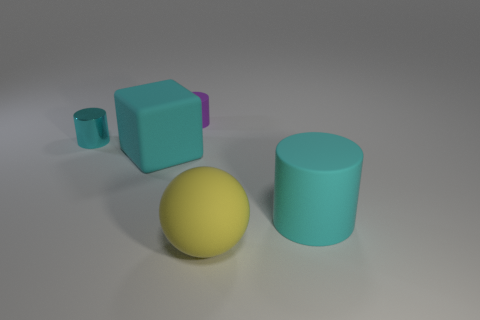Is the number of large yellow spheres that are behind the ball less than the number of large cylinders in front of the large cylinder?
Your answer should be very brief. No. Are there any other things that have the same size as the cyan block?
Your answer should be compact. Yes. What is the shape of the big yellow object?
Provide a short and direct response. Sphere. What is the cyan cylinder that is on the right side of the yellow matte sphere made of?
Offer a very short reply. Rubber. There is a thing that is behind the cyan object that is behind the cyan rubber thing left of the cyan matte cylinder; what size is it?
Give a very brief answer. Small. Is the material of the big object that is in front of the big matte cylinder the same as the large cyan thing behind the big matte cylinder?
Your answer should be compact. Yes. How many other things are there of the same color as the tiny shiny object?
Provide a short and direct response. 2. What number of things are big cyan objects on the left side of the large cylinder or small cylinders that are to the right of the small shiny thing?
Ensure brevity in your answer.  2. There is a cyan rubber object behind the cyan thing that is on the right side of the big cyan block; how big is it?
Ensure brevity in your answer.  Large. How big is the yellow object?
Provide a short and direct response. Large. 